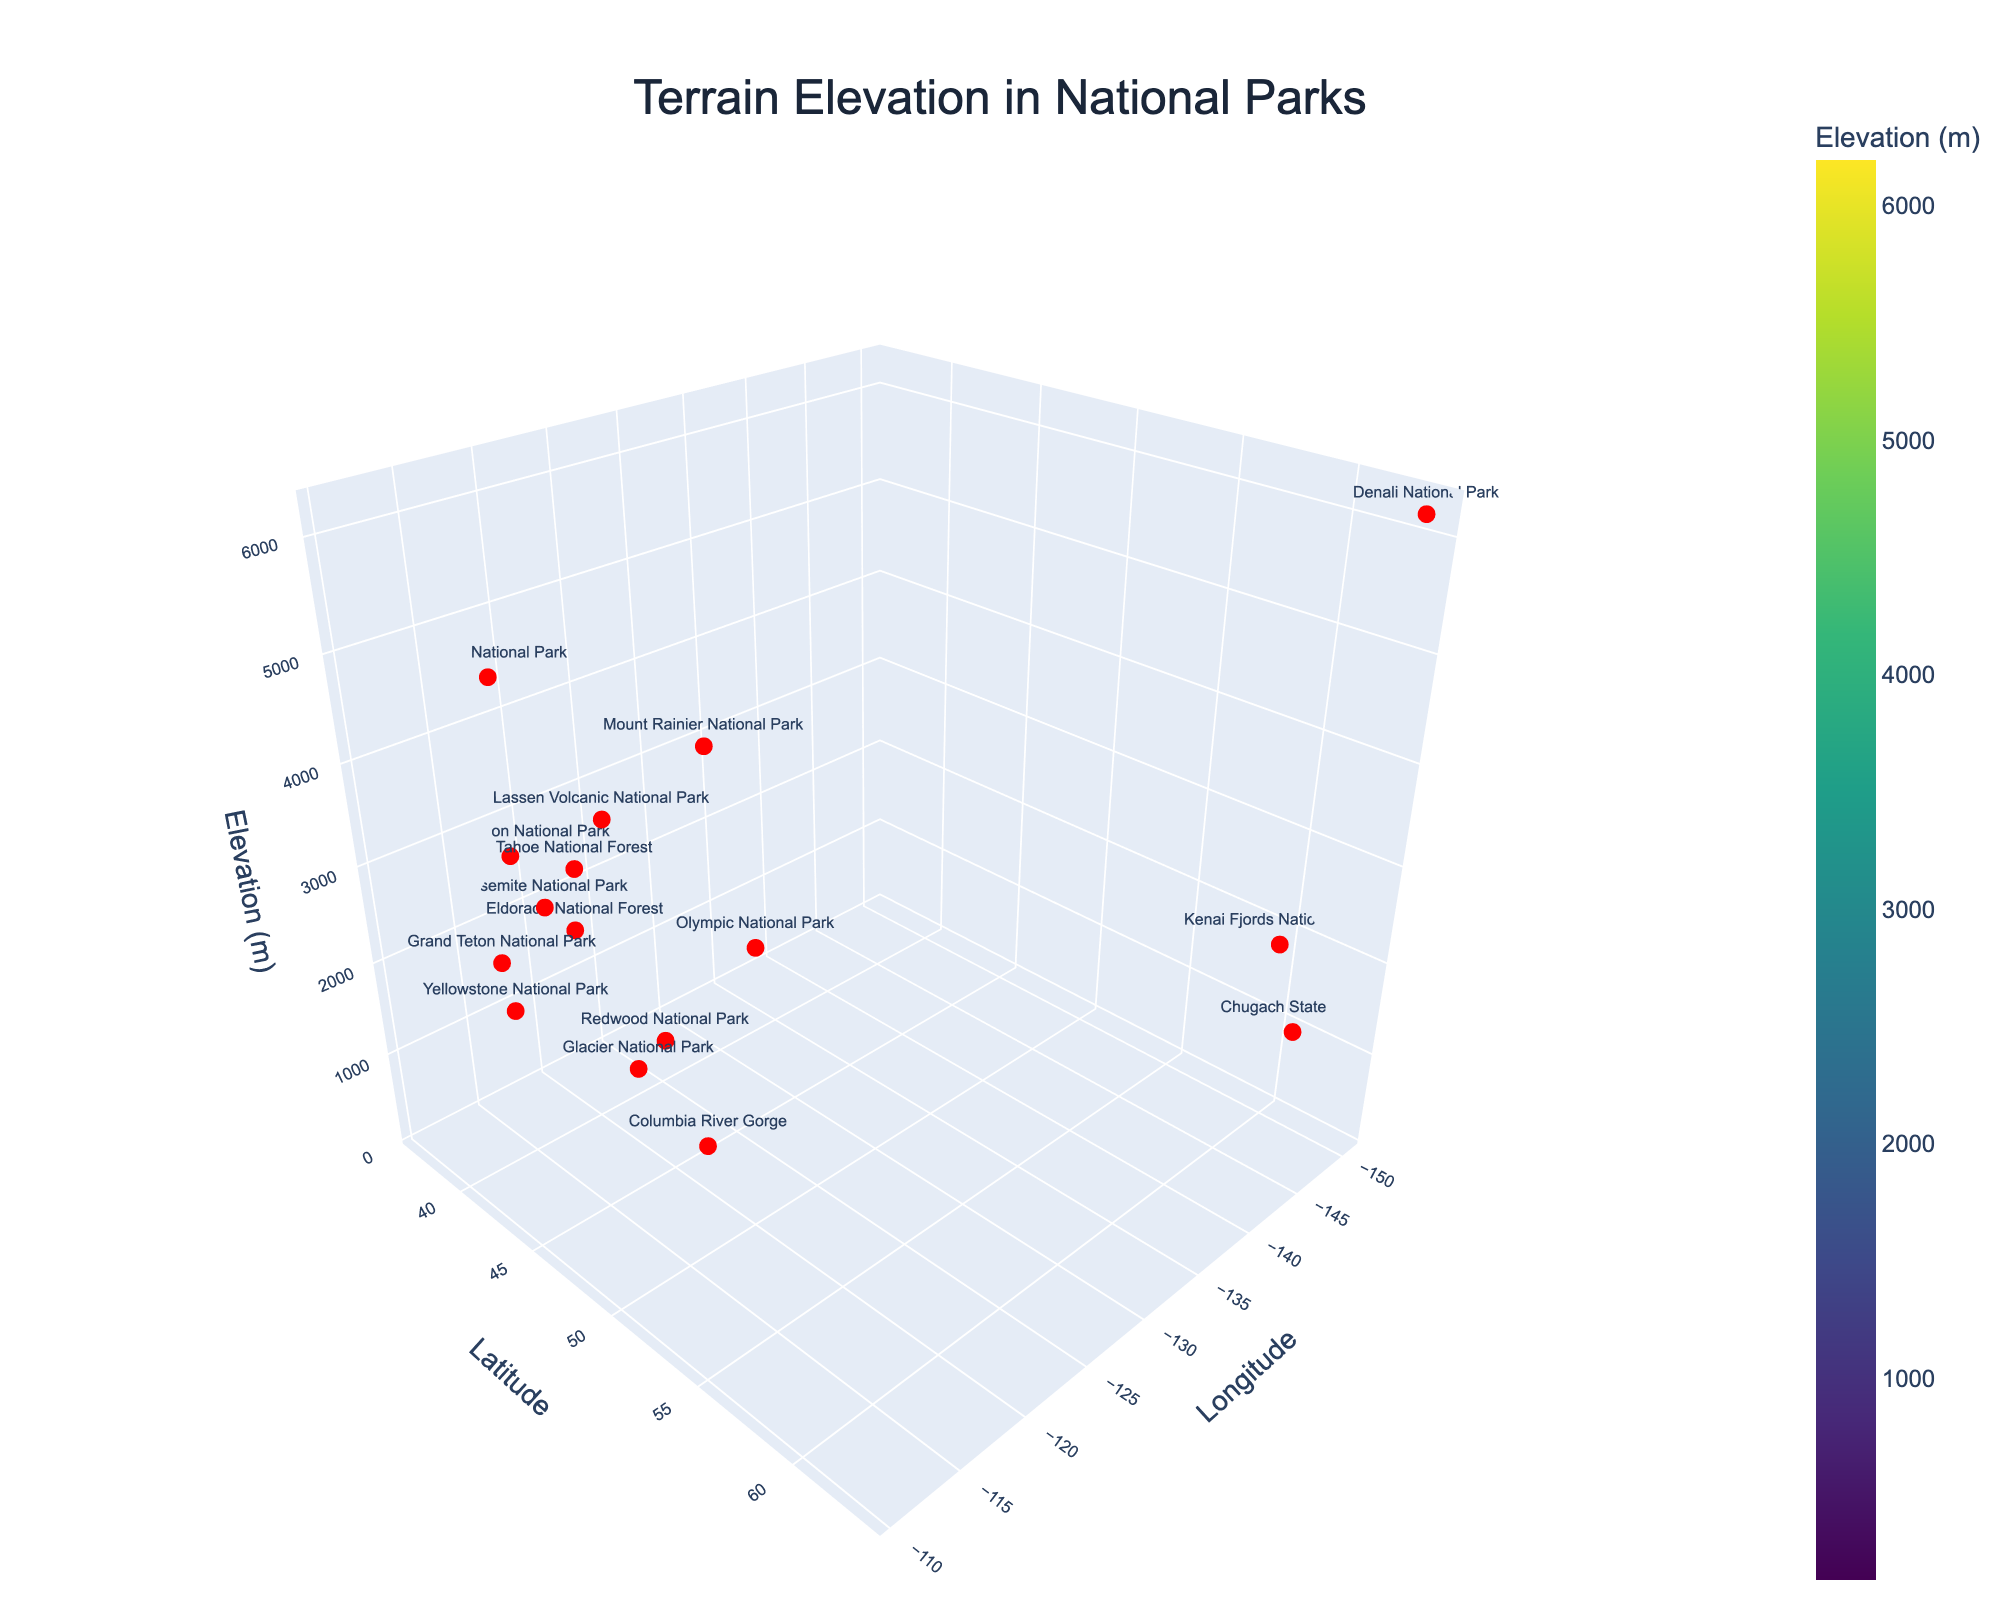What's the title of the figure? The title of the figure is displayed at the top center of the plot. It provides an overview of what the plot represents.
Answer: Terrain Elevation in National Parks What are the axes titles? The axes titles are shown on the respective axes of the 3D plot. They label each axis to indicate the type of data being represented.
Answer: Longitude, Latitude, Elevation (m) How many national parks are represented in the plot? Each red marker represents a national park, and the park names are labeled next to the markers. By counting these labels, you can determine the number of national parks.
Answer: 16 What is the elevation range of the national parks in the plot? The elevation range can be determined by checking the highest and lowest points on the elevation axis. The color gradient also helps identify different elevation levels.
Answer: 142 to 6190 meters Which national park has the highest elevation? The highest elevation point can be found by looking at the topmost red marker labeled with the park's name.
Answer: Denali National Park Which two national parks are the closest in terms of elevation? To find the closest elevations, compare the heights of the markers and look for pairs that are near each other along the elevation axis while keeping an eye on their names.
Answer: Kings Canyon National Park and Tahoe National Forest What is the difference in elevation between Mount Rainier National Park and Yosemite National Park? From the plot, identify the elevations of both parks, then subtract the lower elevation from the higher one to find the difference.
Answer: 2265 meters How does the elevation of Olympic National Park compare to that of Grand Teton National Park? Locate both parks on the plot and compare their elevations along the z-axis. This will show which one is higher.
Answer: Olympic National Park has a lower elevation than Grand Teton National Park What is the average elevation of the national parks plotted? Sum the elevations of all 16 national parks and divide by 16 to find the average elevation. The exact numbers can be read from the markers or labels on the plot.
Answer: 2533 meters What trend can you observe regarding the elevations as you move from lower to higher latitudes? Observe the general pattern of the elevation markers as you scan from lower latitude values to higher ones to identify if the elevation increases, decreases, or has no clear trend.
Answer: Elevation tends to vary without a clear trend as latitude increases 